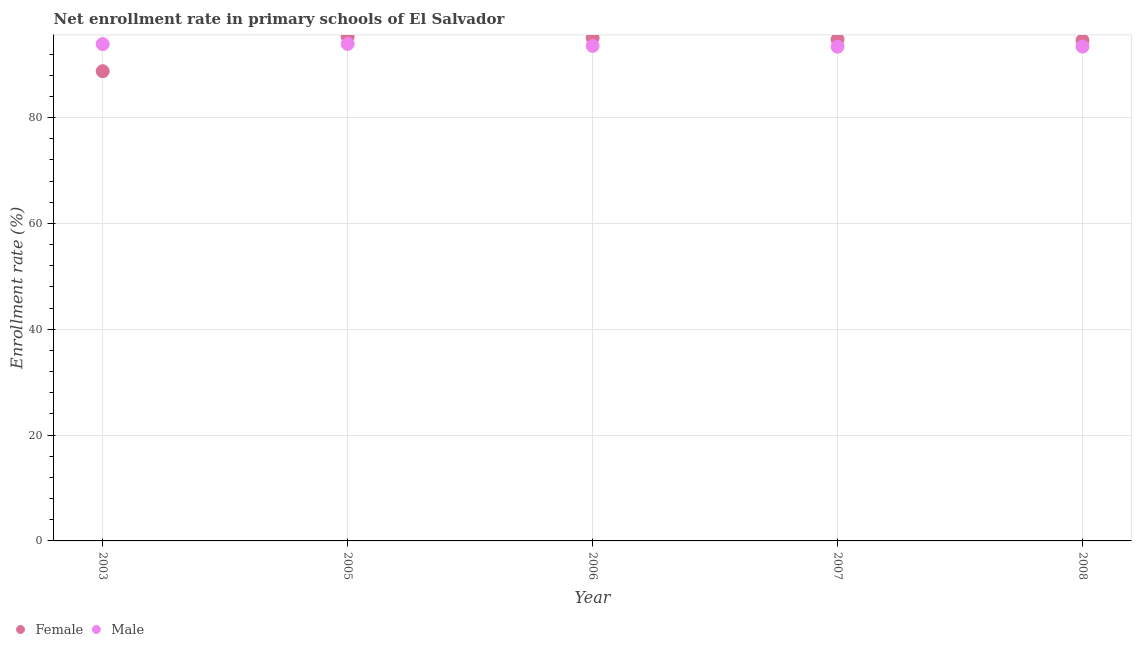Is the number of dotlines equal to the number of legend labels?
Your response must be concise. Yes. What is the enrollment rate of male students in 2005?
Offer a terse response. 93.91. Across all years, what is the maximum enrollment rate of female students?
Give a very brief answer. 95.29. Across all years, what is the minimum enrollment rate of female students?
Ensure brevity in your answer.  88.75. What is the total enrollment rate of male students in the graph?
Your response must be concise. 468.08. What is the difference between the enrollment rate of male students in 2003 and that in 2007?
Ensure brevity in your answer.  0.49. What is the difference between the enrollment rate of male students in 2008 and the enrollment rate of female students in 2005?
Your answer should be very brief. -1.89. What is the average enrollment rate of male students per year?
Your response must be concise. 93.62. In the year 2008, what is the difference between the enrollment rate of male students and enrollment rate of female students?
Your answer should be very brief. -1.17. In how many years, is the enrollment rate of female students greater than 60 %?
Your answer should be compact. 5. What is the ratio of the enrollment rate of male students in 2005 to that in 2006?
Provide a short and direct response. 1. Is the enrollment rate of female students in 2006 less than that in 2007?
Your answer should be compact. No. Is the difference between the enrollment rate of female students in 2003 and 2005 greater than the difference between the enrollment rate of male students in 2003 and 2005?
Provide a succinct answer. No. What is the difference between the highest and the second highest enrollment rate of female students?
Ensure brevity in your answer.  0.25. What is the difference between the highest and the lowest enrollment rate of female students?
Provide a short and direct response. 6.54. Is the sum of the enrollment rate of male students in 2003 and 2006 greater than the maximum enrollment rate of female students across all years?
Ensure brevity in your answer.  Yes. Does the enrollment rate of female students monotonically increase over the years?
Ensure brevity in your answer.  No. Is the enrollment rate of female students strictly greater than the enrollment rate of male students over the years?
Your answer should be very brief. No. How many years are there in the graph?
Your response must be concise. 5. Are the values on the major ticks of Y-axis written in scientific E-notation?
Provide a short and direct response. No. Does the graph contain grids?
Make the answer very short. Yes. How many legend labels are there?
Keep it short and to the point. 2. How are the legend labels stacked?
Provide a succinct answer. Horizontal. What is the title of the graph?
Your answer should be compact. Net enrollment rate in primary schools of El Salvador. What is the label or title of the X-axis?
Your answer should be compact. Year. What is the label or title of the Y-axis?
Provide a short and direct response. Enrollment rate (%). What is the Enrollment rate (%) of Female in 2003?
Keep it short and to the point. 88.75. What is the Enrollment rate (%) in Male in 2003?
Give a very brief answer. 93.87. What is the Enrollment rate (%) of Female in 2005?
Offer a very short reply. 95.29. What is the Enrollment rate (%) of Male in 2005?
Keep it short and to the point. 93.91. What is the Enrollment rate (%) of Female in 2006?
Provide a succinct answer. 95.04. What is the Enrollment rate (%) of Male in 2006?
Give a very brief answer. 93.53. What is the Enrollment rate (%) in Female in 2007?
Keep it short and to the point. 94.75. What is the Enrollment rate (%) in Male in 2007?
Your response must be concise. 93.38. What is the Enrollment rate (%) in Female in 2008?
Ensure brevity in your answer.  94.57. What is the Enrollment rate (%) of Male in 2008?
Keep it short and to the point. 93.4. Across all years, what is the maximum Enrollment rate (%) in Female?
Give a very brief answer. 95.29. Across all years, what is the maximum Enrollment rate (%) of Male?
Your answer should be compact. 93.91. Across all years, what is the minimum Enrollment rate (%) of Female?
Make the answer very short. 88.75. Across all years, what is the minimum Enrollment rate (%) of Male?
Ensure brevity in your answer.  93.38. What is the total Enrollment rate (%) of Female in the graph?
Give a very brief answer. 468.4. What is the total Enrollment rate (%) in Male in the graph?
Your answer should be very brief. 468.08. What is the difference between the Enrollment rate (%) of Female in 2003 and that in 2005?
Ensure brevity in your answer.  -6.54. What is the difference between the Enrollment rate (%) of Male in 2003 and that in 2005?
Your response must be concise. -0.04. What is the difference between the Enrollment rate (%) in Female in 2003 and that in 2006?
Provide a short and direct response. -6.29. What is the difference between the Enrollment rate (%) of Male in 2003 and that in 2006?
Offer a terse response. 0.34. What is the difference between the Enrollment rate (%) in Female in 2003 and that in 2007?
Offer a very short reply. -6. What is the difference between the Enrollment rate (%) in Male in 2003 and that in 2007?
Give a very brief answer. 0.49. What is the difference between the Enrollment rate (%) of Female in 2003 and that in 2008?
Your answer should be very brief. -5.83. What is the difference between the Enrollment rate (%) of Male in 2003 and that in 2008?
Provide a short and direct response. 0.47. What is the difference between the Enrollment rate (%) of Female in 2005 and that in 2006?
Your answer should be compact. 0.25. What is the difference between the Enrollment rate (%) of Male in 2005 and that in 2006?
Provide a short and direct response. 0.38. What is the difference between the Enrollment rate (%) in Female in 2005 and that in 2007?
Make the answer very short. 0.54. What is the difference between the Enrollment rate (%) in Male in 2005 and that in 2007?
Provide a short and direct response. 0.53. What is the difference between the Enrollment rate (%) in Female in 2005 and that in 2008?
Give a very brief answer. 0.71. What is the difference between the Enrollment rate (%) of Male in 2005 and that in 2008?
Provide a short and direct response. 0.51. What is the difference between the Enrollment rate (%) of Female in 2006 and that in 2007?
Your response must be concise. 0.29. What is the difference between the Enrollment rate (%) of Male in 2006 and that in 2007?
Your answer should be compact. 0.15. What is the difference between the Enrollment rate (%) in Female in 2006 and that in 2008?
Your answer should be very brief. 0.46. What is the difference between the Enrollment rate (%) of Male in 2006 and that in 2008?
Your answer should be very brief. 0.13. What is the difference between the Enrollment rate (%) in Female in 2007 and that in 2008?
Ensure brevity in your answer.  0.18. What is the difference between the Enrollment rate (%) of Male in 2007 and that in 2008?
Your answer should be compact. -0.02. What is the difference between the Enrollment rate (%) in Female in 2003 and the Enrollment rate (%) in Male in 2005?
Provide a short and direct response. -5.16. What is the difference between the Enrollment rate (%) of Female in 2003 and the Enrollment rate (%) of Male in 2006?
Keep it short and to the point. -4.78. What is the difference between the Enrollment rate (%) of Female in 2003 and the Enrollment rate (%) of Male in 2007?
Your answer should be very brief. -4.63. What is the difference between the Enrollment rate (%) in Female in 2003 and the Enrollment rate (%) in Male in 2008?
Your response must be concise. -4.65. What is the difference between the Enrollment rate (%) of Female in 2005 and the Enrollment rate (%) of Male in 2006?
Your answer should be very brief. 1.76. What is the difference between the Enrollment rate (%) in Female in 2005 and the Enrollment rate (%) in Male in 2007?
Provide a short and direct response. 1.91. What is the difference between the Enrollment rate (%) of Female in 2005 and the Enrollment rate (%) of Male in 2008?
Ensure brevity in your answer.  1.89. What is the difference between the Enrollment rate (%) of Female in 2006 and the Enrollment rate (%) of Male in 2007?
Your answer should be very brief. 1.66. What is the difference between the Enrollment rate (%) in Female in 2006 and the Enrollment rate (%) in Male in 2008?
Your answer should be very brief. 1.64. What is the difference between the Enrollment rate (%) of Female in 2007 and the Enrollment rate (%) of Male in 2008?
Your answer should be very brief. 1.35. What is the average Enrollment rate (%) in Female per year?
Provide a succinct answer. 93.68. What is the average Enrollment rate (%) in Male per year?
Offer a very short reply. 93.62. In the year 2003, what is the difference between the Enrollment rate (%) in Female and Enrollment rate (%) in Male?
Offer a very short reply. -5.12. In the year 2005, what is the difference between the Enrollment rate (%) in Female and Enrollment rate (%) in Male?
Provide a succinct answer. 1.38. In the year 2006, what is the difference between the Enrollment rate (%) of Female and Enrollment rate (%) of Male?
Make the answer very short. 1.51. In the year 2007, what is the difference between the Enrollment rate (%) in Female and Enrollment rate (%) in Male?
Your answer should be compact. 1.37. In the year 2008, what is the difference between the Enrollment rate (%) of Female and Enrollment rate (%) of Male?
Your answer should be compact. 1.17. What is the ratio of the Enrollment rate (%) of Female in 2003 to that in 2005?
Your response must be concise. 0.93. What is the ratio of the Enrollment rate (%) in Male in 2003 to that in 2005?
Your answer should be very brief. 1. What is the ratio of the Enrollment rate (%) of Female in 2003 to that in 2006?
Your answer should be compact. 0.93. What is the ratio of the Enrollment rate (%) of Female in 2003 to that in 2007?
Offer a very short reply. 0.94. What is the ratio of the Enrollment rate (%) of Male in 2003 to that in 2007?
Offer a terse response. 1.01. What is the ratio of the Enrollment rate (%) in Female in 2003 to that in 2008?
Keep it short and to the point. 0.94. What is the ratio of the Enrollment rate (%) of Male in 2005 to that in 2006?
Make the answer very short. 1. What is the ratio of the Enrollment rate (%) in Female in 2005 to that in 2007?
Give a very brief answer. 1.01. What is the ratio of the Enrollment rate (%) in Male in 2005 to that in 2007?
Provide a short and direct response. 1.01. What is the ratio of the Enrollment rate (%) of Female in 2005 to that in 2008?
Provide a succinct answer. 1.01. What is the ratio of the Enrollment rate (%) in Male in 2005 to that in 2008?
Ensure brevity in your answer.  1.01. What is the ratio of the Enrollment rate (%) in Male in 2006 to that in 2007?
Your response must be concise. 1. What is the ratio of the Enrollment rate (%) of Female in 2006 to that in 2008?
Give a very brief answer. 1. What is the ratio of the Enrollment rate (%) in Male in 2006 to that in 2008?
Offer a terse response. 1. What is the ratio of the Enrollment rate (%) in Male in 2007 to that in 2008?
Ensure brevity in your answer.  1. What is the difference between the highest and the second highest Enrollment rate (%) of Female?
Make the answer very short. 0.25. What is the difference between the highest and the second highest Enrollment rate (%) in Male?
Keep it short and to the point. 0.04. What is the difference between the highest and the lowest Enrollment rate (%) in Female?
Give a very brief answer. 6.54. What is the difference between the highest and the lowest Enrollment rate (%) of Male?
Offer a terse response. 0.53. 